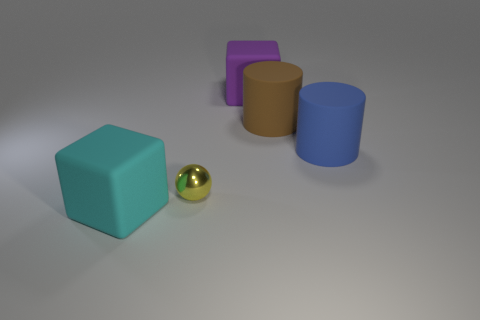Add 2 big cyan metallic blocks. How many objects exist? 7 Subtract 1 yellow spheres. How many objects are left? 4 Subtract all cubes. How many objects are left? 3 Subtract all cyan blocks. Subtract all yellow metal objects. How many objects are left? 3 Add 2 yellow balls. How many yellow balls are left? 3 Add 1 tiny gray metal blocks. How many tiny gray metal blocks exist? 1 